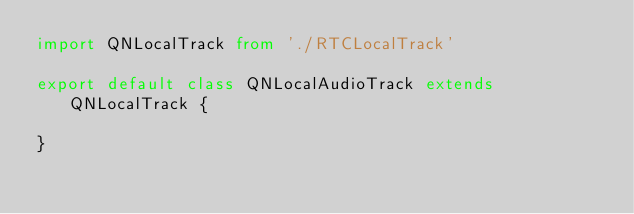<code> <loc_0><loc_0><loc_500><loc_500><_TypeScript_>import QNLocalTrack from './RTCLocalTrack'

export default class QNLocalAudioTrack extends QNLocalTrack {

}
</code> 